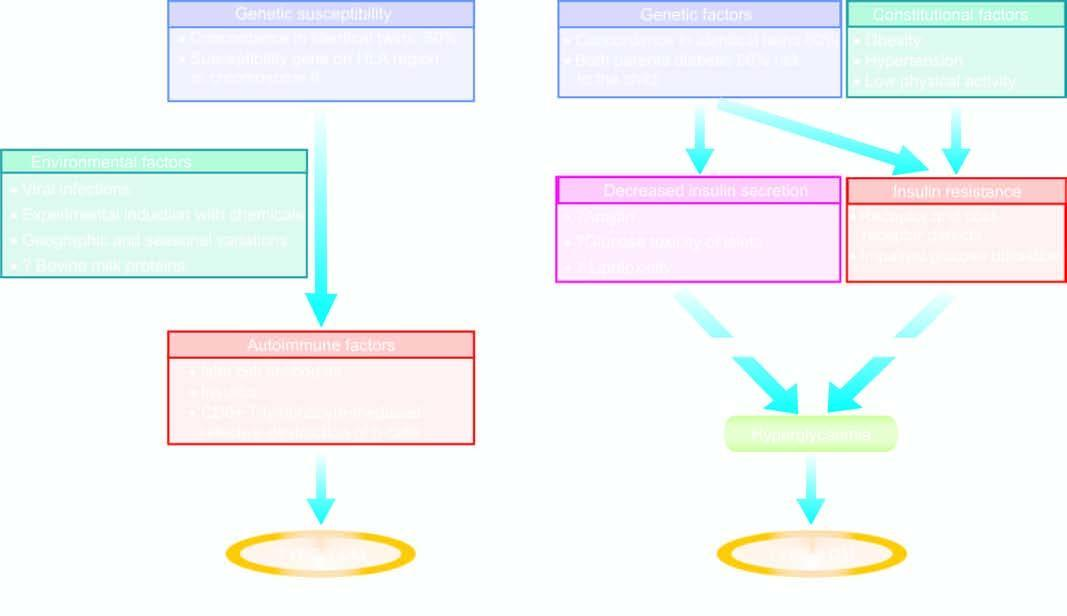what is chematic mechanisms involved in?
Answer the question using a single word or phrase. Pathogenesis of two main types of diabetes mellitus 